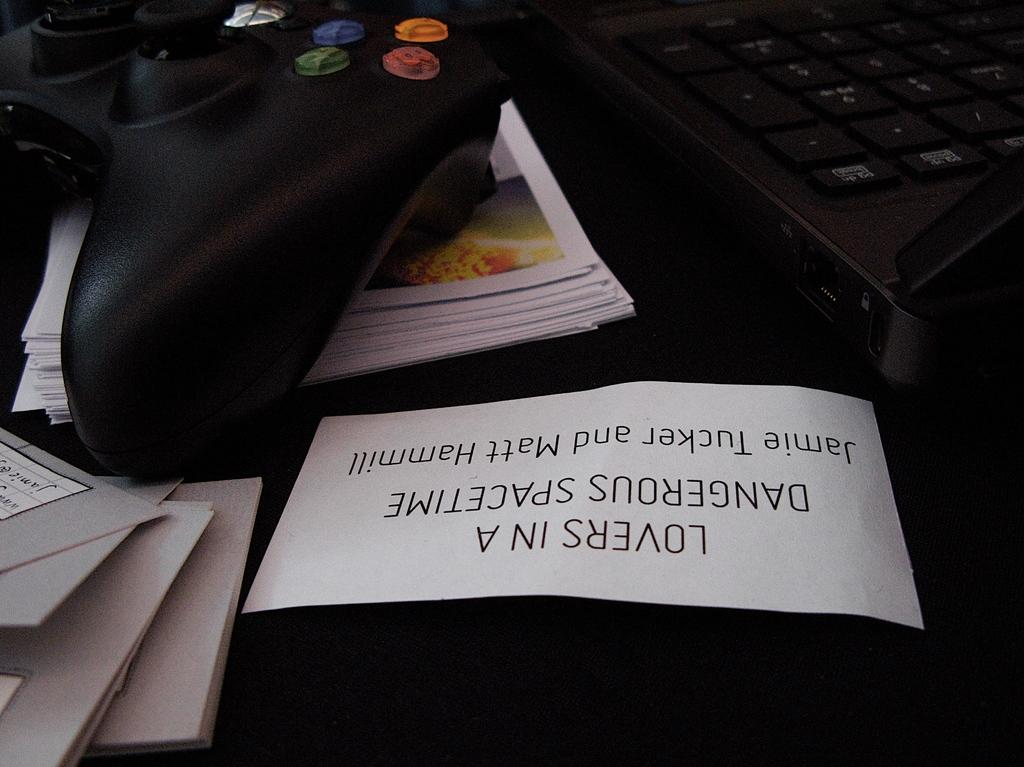<image>
Write a terse but informative summary of the picture. A controller and a piece of paper with the names Jamie Tucker and Matt Hammill. 